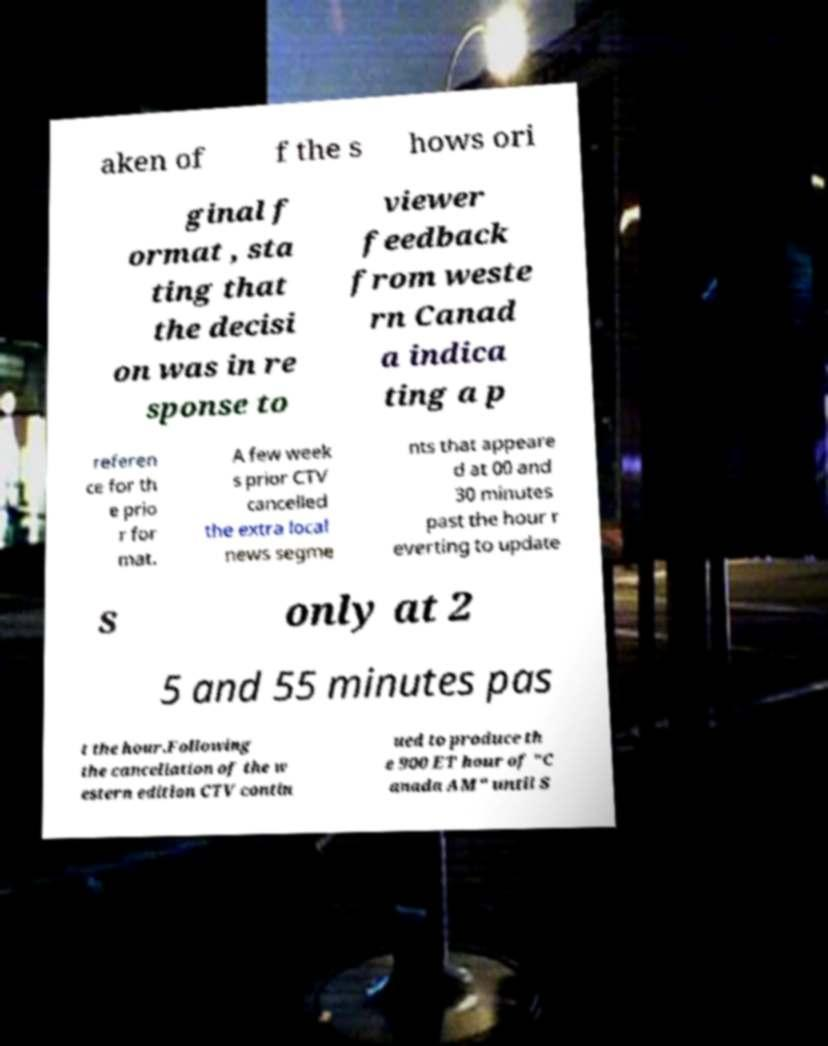Please identify and transcribe the text found in this image. aken of f the s hows ori ginal f ormat , sta ting that the decisi on was in re sponse to viewer feedback from weste rn Canad a indica ting a p referen ce for th e prio r for mat. A few week s prior CTV cancelled the extra local news segme nts that appeare d at 00 and 30 minutes past the hour r everting to update s only at 2 5 and 55 minutes pas t the hour.Following the cancellation of the w estern edition CTV contin ued to produce th e 900 ET hour of "C anada AM" until S 